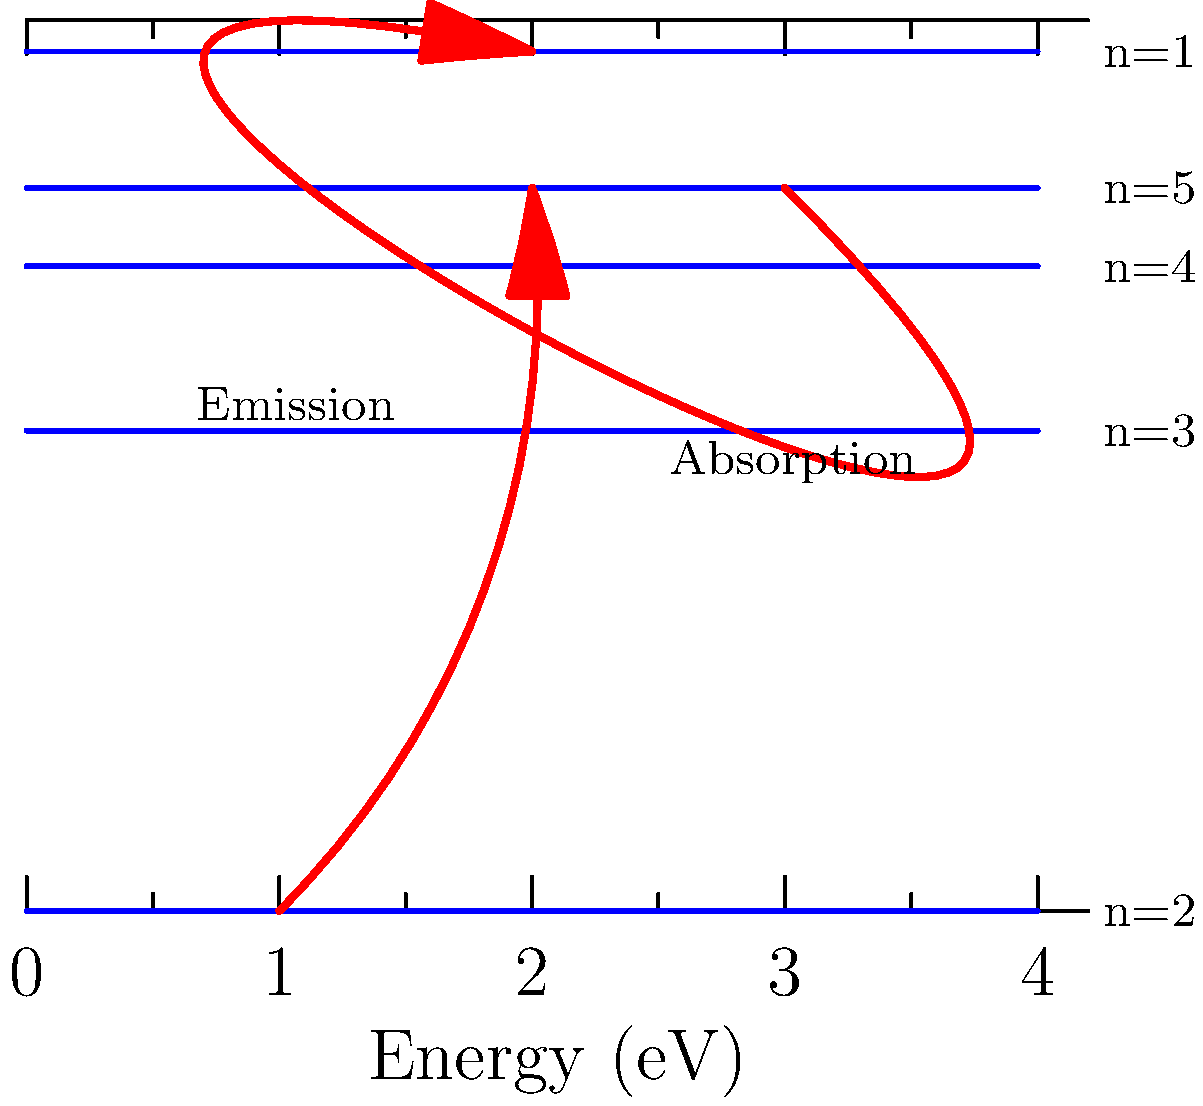In the context of the Bohr model and quantum mechanics, analyze the energy diagram provided. Identify the transition that represents the emission of a photon with the highest energy, and calculate its wavelength in nanometers. Given: The Planck constant $h = 6.626 \times 10^{-34}$ J·s, and the speed of light $c = 2.998 \times 10^8$ m/s. To solve this problem, we'll follow these steps:

1) Identify the transition with the highest energy emission:
   The transition from n=5 to n=1 represents the emission of a photon with the highest energy.

2) Calculate the energy difference:
   $\Delta E = E_{final} - E_{initial} = -3.4 \text{ eV} - (-0.54 \text{ eV}) = -2.86 \text{ eV}$

3) Convert the energy from eV to Joules:
   $\Delta E = 2.86 \text{ eV} \times 1.602 \times 10^{-19} \text{ J/eV} = 4.58 \times 10^{-19} \text{ J}$

4) Use the equation relating energy and wavelength:
   $E = \frac{hc}{\lambda}$

5) Rearrange to solve for wavelength:
   $\lambda = \frac{hc}{E}$

6) Substitute the values:
   $\lambda = \frac{(6.626 \times 10^{-34} \text{ J·s})(2.998 \times 10^8 \text{ m/s})}{4.58 \times 10^{-19} \text{ J}}$

7) Calculate:
   $\lambda = 4.33 \times 10^{-7} \text{ m} = 433 \text{ nm}$

Therefore, the wavelength of the emitted photon is 433 nm.
Answer: 433 nm 